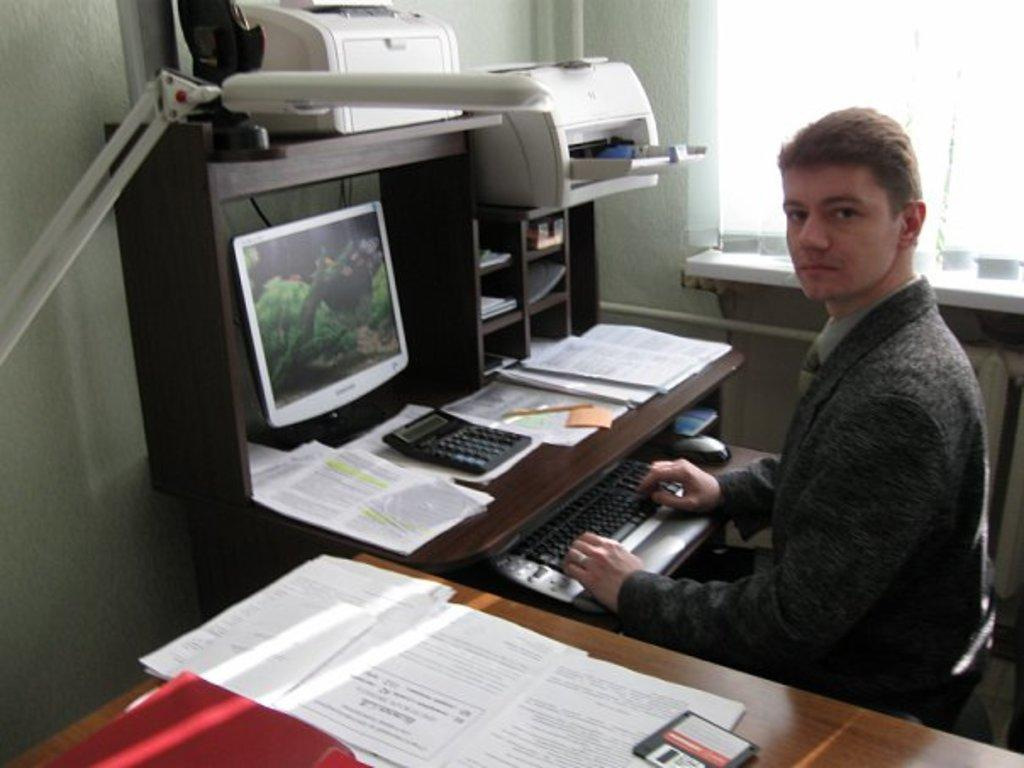What is the guy in the image doing? The guy is sitting in front of a monitor. What objects are on the table in the image? There are notebooks, a pen, and two white machines on the table. What type of receipt can be seen in the image? There is no receipt present in the image. Can you describe the basin in the image? There is no basin present in the image. 